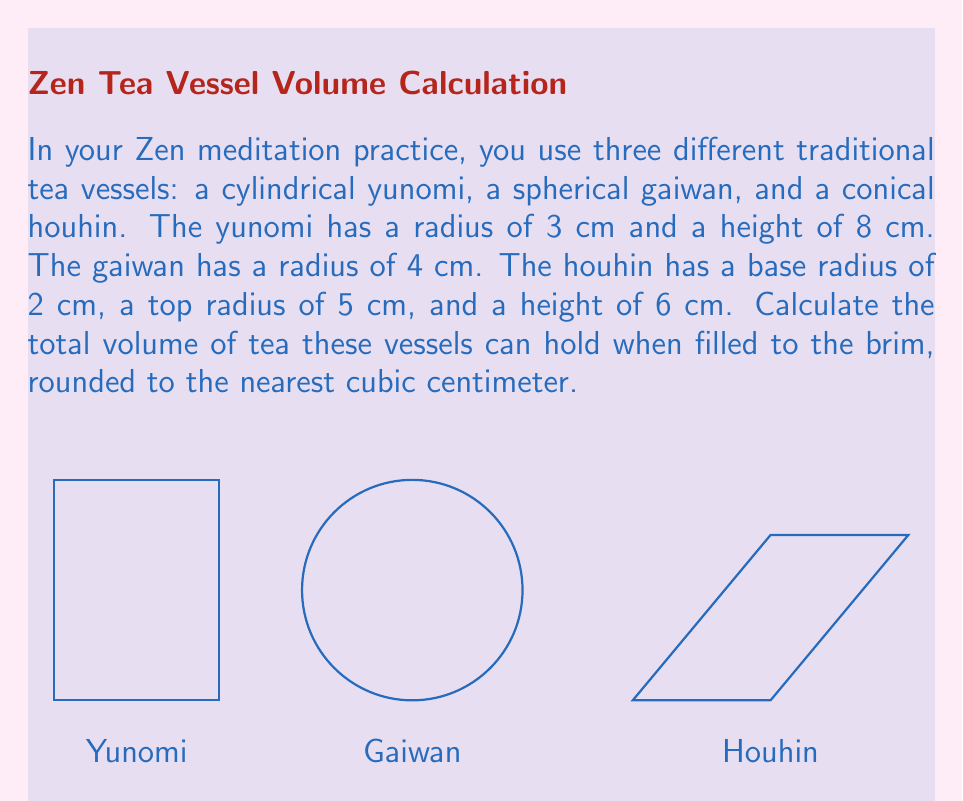Show me your answer to this math problem. Let's calculate the volume of each vessel separately:

1. Yunomi (cylinder):
   Volume = $\pi r^2 h$
   $V_y = \pi \cdot 3^2 \cdot 8 = 72\pi$ cm³

2. Gaiwan (sphere):
   Volume = $\frac{4}{3}\pi r^3$
   $V_g = \frac{4}{3}\pi \cdot 4^3 = \frac{256}{3}\pi$ cm³

3. Houhin (truncated cone):
   Volume = $\frac{1}{3}\pi h(R^2 + r^2 + Rr)$, where R is the top radius and r is the base radius
   $V_h = \frac{1}{3}\pi \cdot 6(5^2 + 2^2 + 5 \cdot 2) = 70\pi$ cm³

Total volume:
$V_{total} = V_y + V_g + V_h$
$V_{total} = 72\pi + \frac{256}{3}\pi + 70\pi$
$V_{total} = (72 + \frac{256}{3} + 70)\pi$
$V_{total} = \frac{698}{3}\pi \approx 731.6$ cm³

Rounding to the nearest cubic centimeter: 732 cm³
Answer: 732 cm³ 